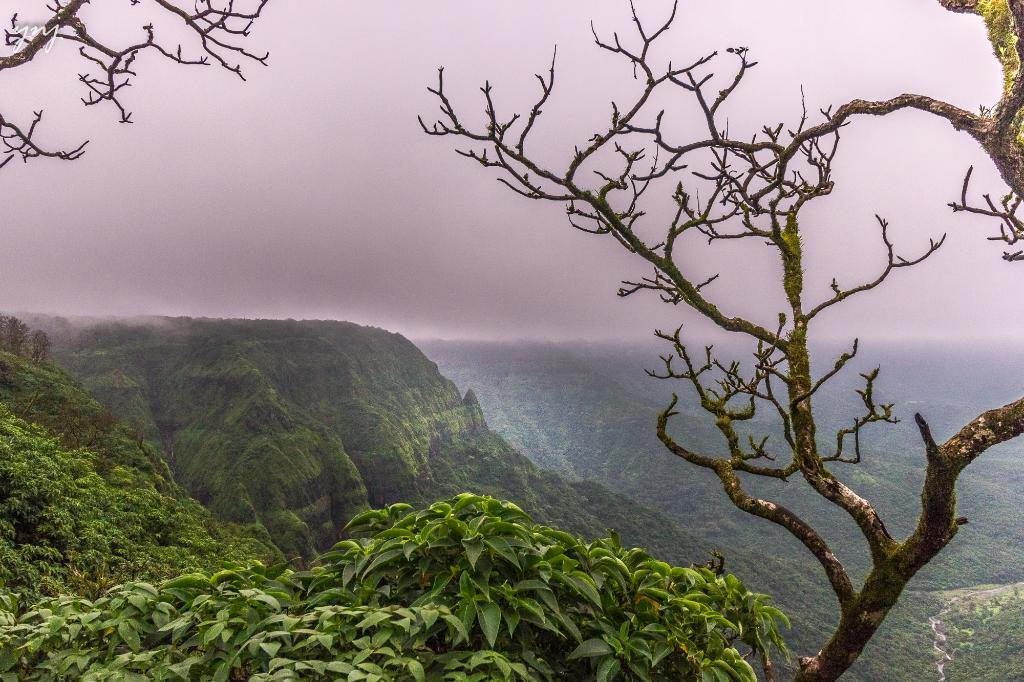What type of natural environment is visible in the image? There is greenery visible in the image. How many tickets are visible in the image? There are no tickets present in the image; it only features greenery. What type of clothing material is visible in the image? There is no clothing material visible in the image; it only features greenery. 